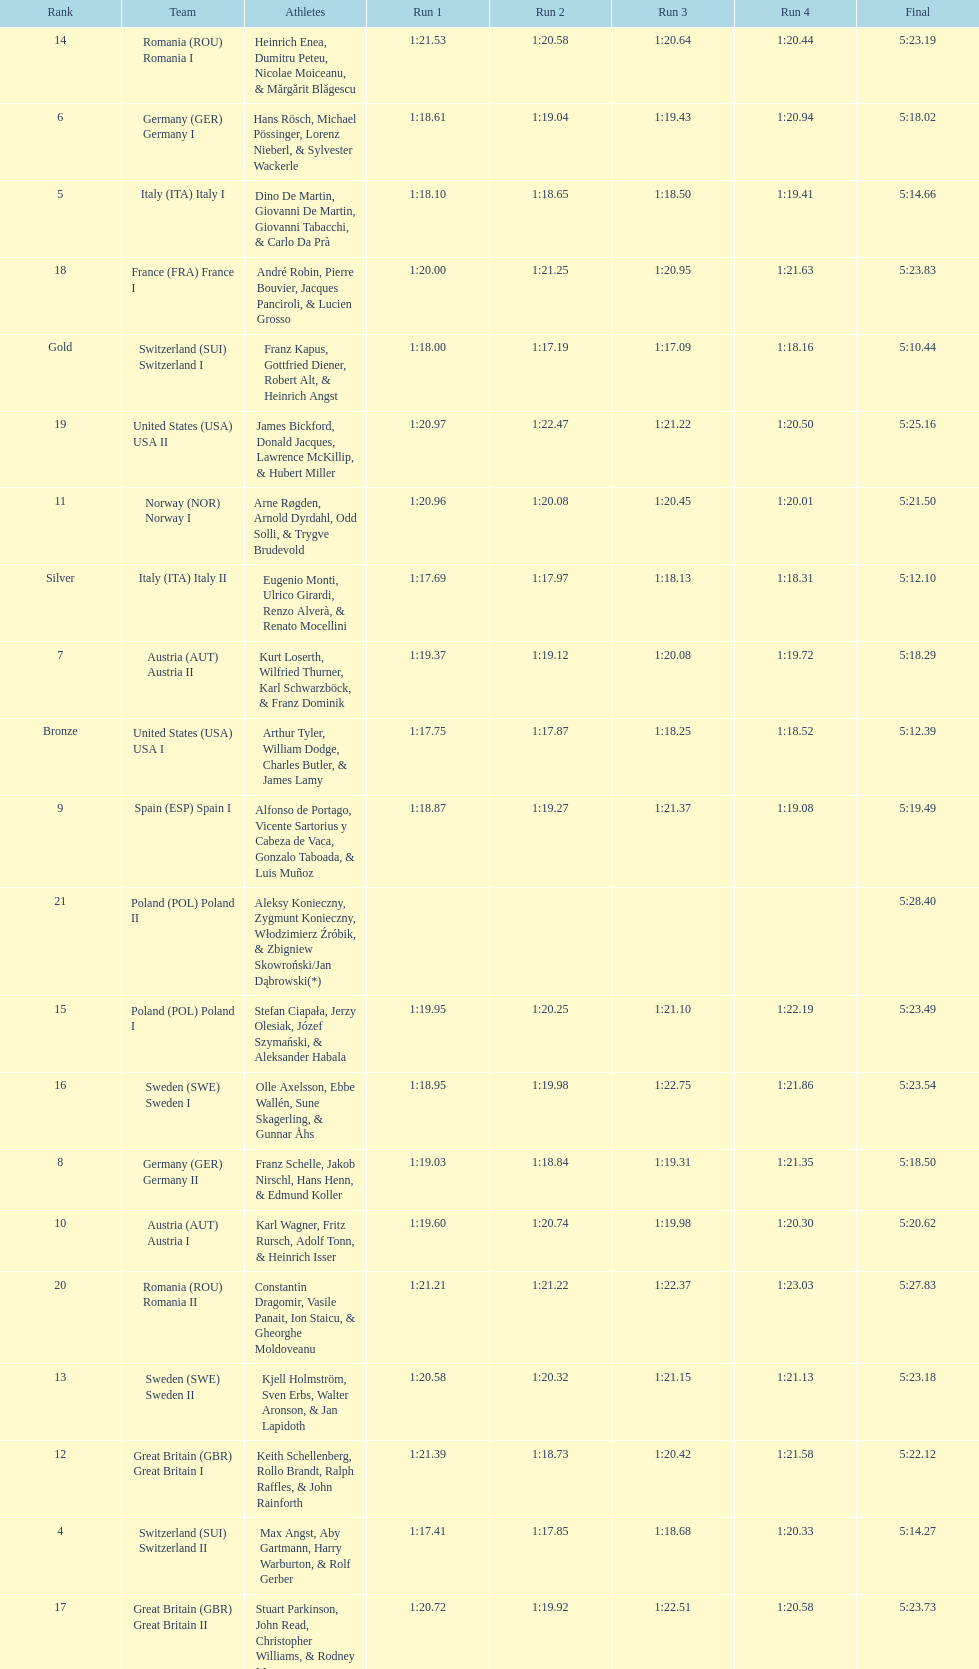What team came out on top? Switzerland. 